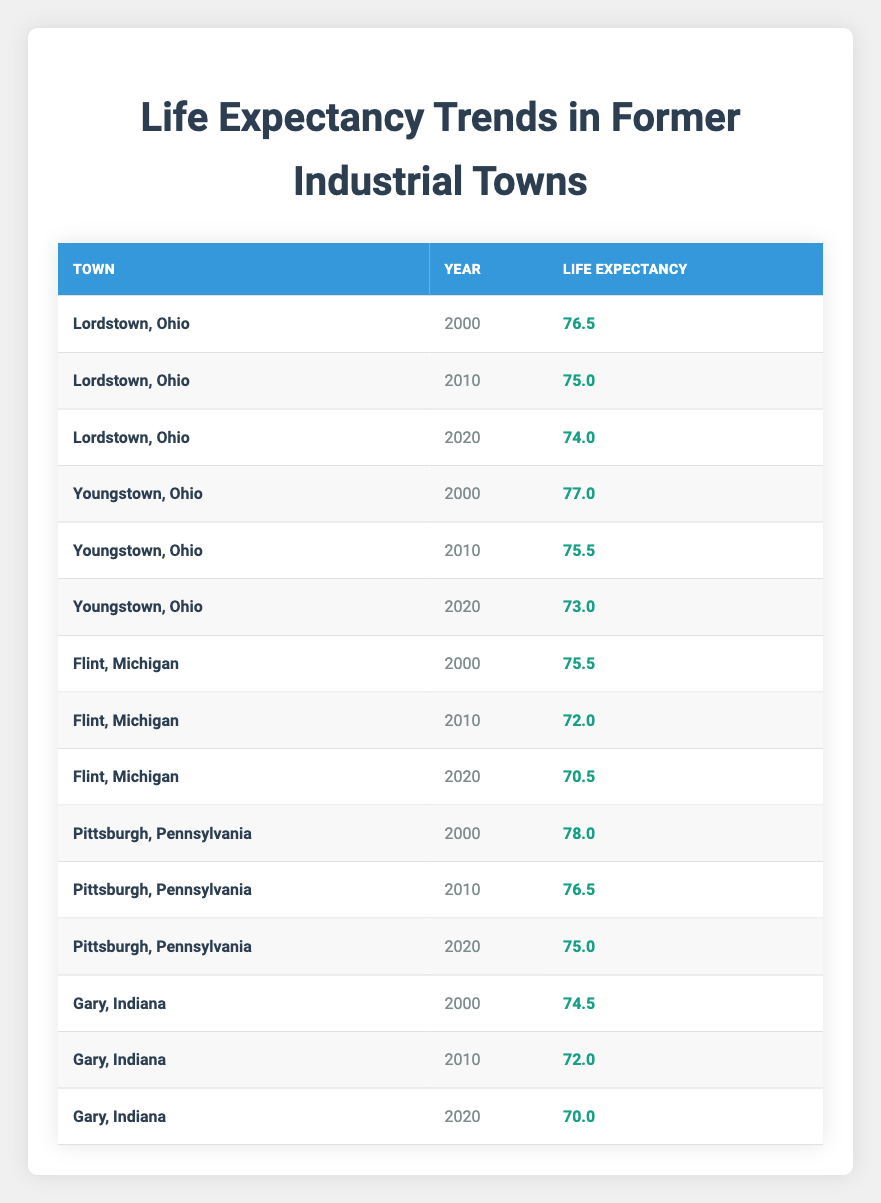What was the life expectancy in Lordstown, Ohio in 2010? The table shows that the life expectancy for Lordstown, Ohio in 2010 is listed as 75.0.
Answer: 75.0 Which town had the highest life expectancy in the year 2000? According to the table, Pittsburgh, Pennsylvania had the highest life expectancy of 78.0 in the year 2000 compared to other towns.
Answer: Pittsburgh, Pennsylvania What is the difference in life expectancy for Flint, Michigan from 2000 to 2020? The life expectancy for Flint, Michigan was 75.5 in 2000 and decreased to 70.5 in 2020. The difference is calculated as 75.5 - 70.5 = 5.0.
Answer: 5.0 Is the life expectancy for Gary, Indiana consistently declining from 2000 to 2020? Upon checking the values: 74.5 in 2000, 72.0 in 2010, and 70.0 in 2020, it shows a consistent decline year over year. Hence, the answer is true.
Answer: Yes What is the average life expectancy for Youngstown, Ohio over the provided years? Youngstown had life expectancies of 77.0 in 2000, 75.5 in 2010, and 73.0 in 2020. Summing these gives 77.0 + 75.5 + 73.0 = 225.5. Dividing by 3 (the number of data points) results in an average of 225.5 / 3 = 75.17.
Answer: 75.17 